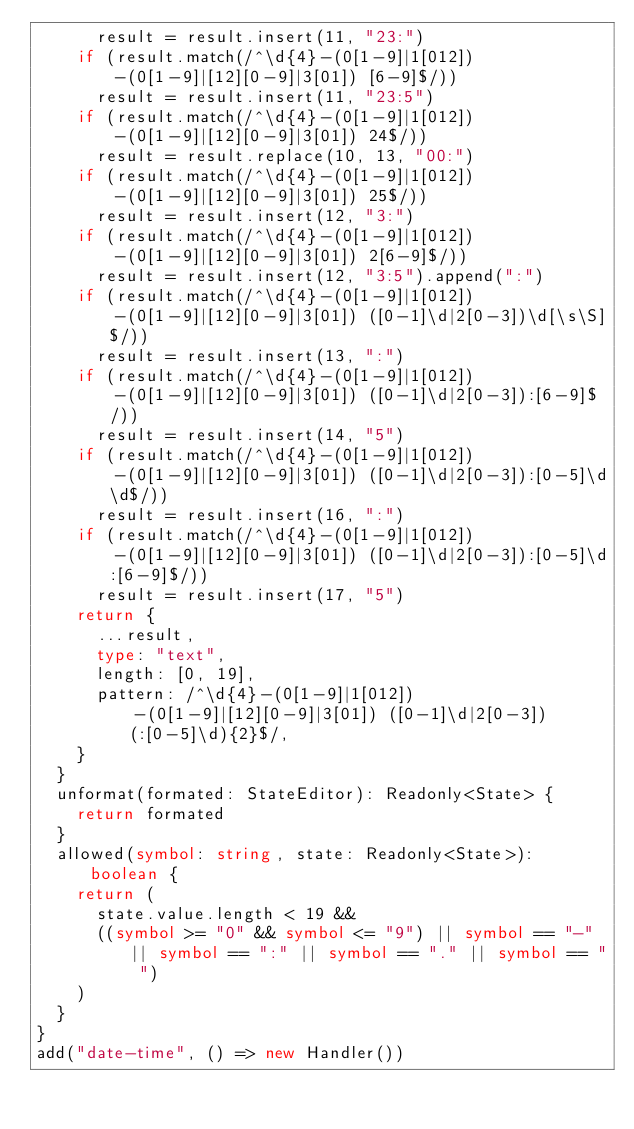<code> <loc_0><loc_0><loc_500><loc_500><_TypeScript_>			result = result.insert(11, "23:")
		if (result.match(/^\d{4}-(0[1-9]|1[012])-(0[1-9]|[12][0-9]|3[01]) [6-9]$/))
			result = result.insert(11, "23:5")
		if (result.match(/^\d{4}-(0[1-9]|1[012])-(0[1-9]|[12][0-9]|3[01]) 24$/))
			result = result.replace(10, 13, "00:")
		if (result.match(/^\d{4}-(0[1-9]|1[012])-(0[1-9]|[12][0-9]|3[01]) 25$/))
			result = result.insert(12, "3:")
		if (result.match(/^\d{4}-(0[1-9]|1[012])-(0[1-9]|[12][0-9]|3[01]) 2[6-9]$/))
			result = result.insert(12, "3:5").append(":")
		if (result.match(/^\d{4}-(0[1-9]|1[012])-(0[1-9]|[12][0-9]|3[01]) ([0-1]\d|2[0-3])\d[\s\S]$/))
			result = result.insert(13, ":")
		if (result.match(/^\d{4}-(0[1-9]|1[012])-(0[1-9]|[12][0-9]|3[01]) ([0-1]\d|2[0-3]):[6-9]$/))
			result = result.insert(14, "5")
		if (result.match(/^\d{4}-(0[1-9]|1[012])-(0[1-9]|[12][0-9]|3[01]) ([0-1]\d|2[0-3]):[0-5]\d\d$/))
			result = result.insert(16, ":")
		if (result.match(/^\d{4}-(0[1-9]|1[012])-(0[1-9]|[12][0-9]|3[01]) ([0-1]\d|2[0-3]):[0-5]\d:[6-9]$/))
			result = result.insert(17, "5")
		return {
			...result,
			type: "text",
			length: [0, 19],
			pattern: /^\d{4}-(0[1-9]|1[012])-(0[1-9]|[12][0-9]|3[01]) ([0-1]\d|2[0-3])(:[0-5]\d){2}$/,
		}
	}
	unformat(formated: StateEditor): Readonly<State> {
		return formated
	}
	allowed(symbol: string, state: Readonly<State>): boolean {
		return (
			state.value.length < 19 &&
			((symbol >= "0" && symbol <= "9") || symbol == "-" || symbol == ":" || symbol == "." || symbol == " ")
		)
	}
}
add("date-time", () => new Handler())
</code> 